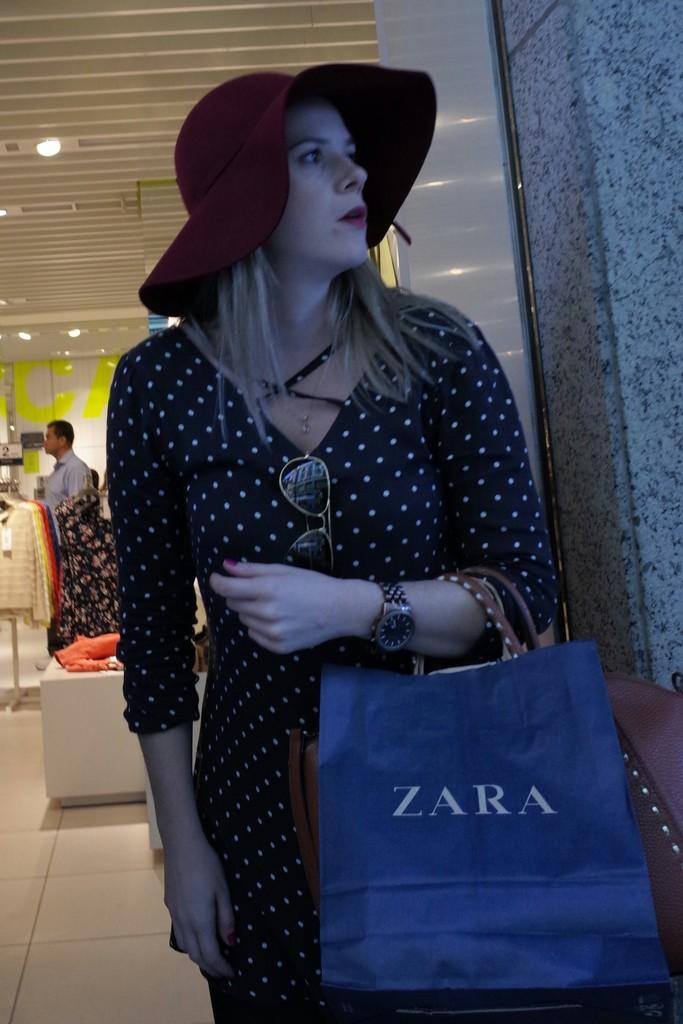What is the person in the foreground of the image doing? The person is standing and holding a bag in the image. What can be seen in the background of the image? Tops and lights are visible in the background of the image. Are there any other people present in the image? Yes, there is at least one other person standing in the background of the image. What type of mine can be seen in the image? There is no mine present in the image. 